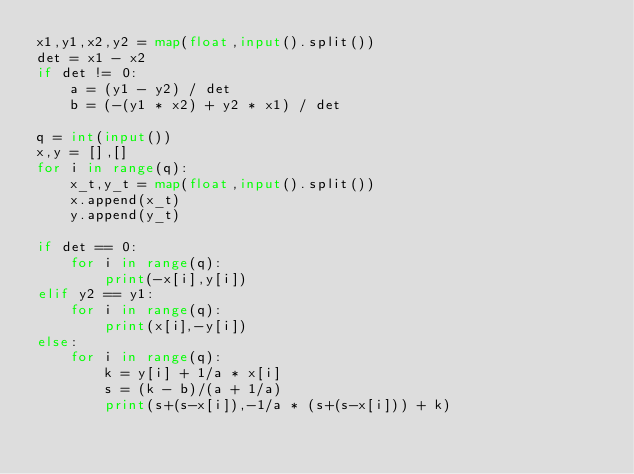<code> <loc_0><loc_0><loc_500><loc_500><_Python_>x1,y1,x2,y2 = map(float,input().split())
det = x1 - x2
if det != 0:
    a = (y1 - y2) / det
    b = (-(y1 * x2) + y2 * x1) / det

q = int(input())
x,y = [],[]
for i in range(q):
    x_t,y_t = map(float,input().split())
    x.append(x_t)
    y.append(y_t)

if det == 0:
    for i in range(q):
        print(-x[i],y[i])
elif y2 == y1:
    for i in range(q):
        print(x[i],-y[i])
else:
    for i in range(q):
        k = y[i] + 1/a * x[i]
        s = (k - b)/(a + 1/a)
        print(s+(s-x[i]),-1/a * (s+(s-x[i])) + k)</code> 